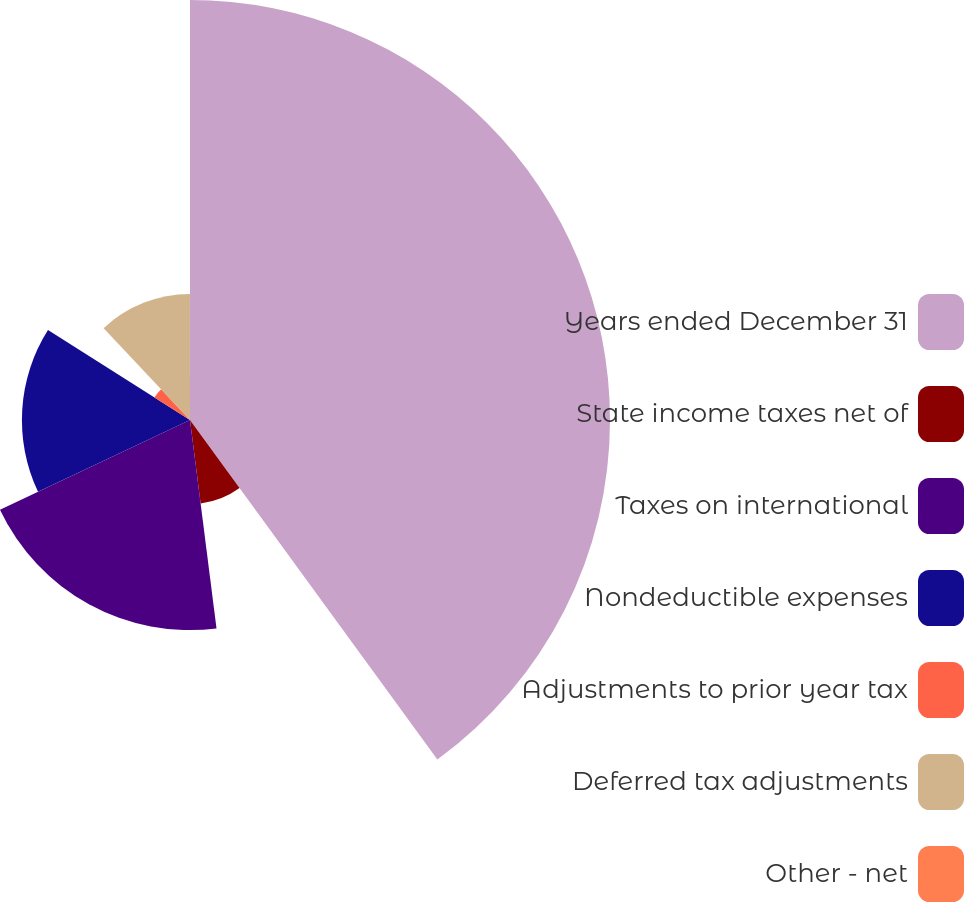<chart> <loc_0><loc_0><loc_500><loc_500><pie_chart><fcel>Years ended December 31<fcel>State income taxes net of<fcel>Taxes on international<fcel>Nondeductible expenses<fcel>Adjustments to prior year tax<fcel>Deferred tax adjustments<fcel>Other - net<nl><fcel>39.98%<fcel>8.01%<fcel>20.0%<fcel>16.0%<fcel>4.01%<fcel>12.0%<fcel>0.01%<nl></chart> 